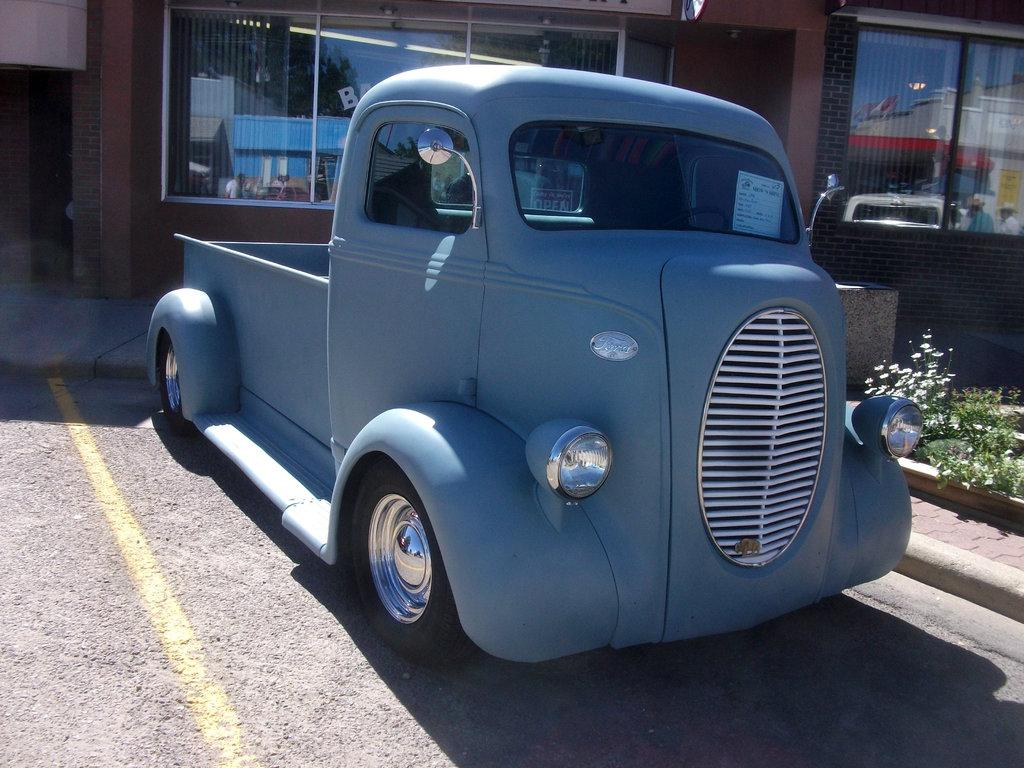What color is the vehicle in the image? The vehicle in the image is gray-colored. Where is the vehicle located in the image? The vehicle is parked on the road. What can be seen at the bottom of the image? There is a road visible at the bottom of the image. What is visible in the background of the image? There is a building in the background of the image. What type of vegetation is on the right side of the image? There are plants on the right side of the image. What type of sheet is covering the vehicle in the image? There is no sheet covering the vehicle in the image; it is parked on the road with no visible coverings. 